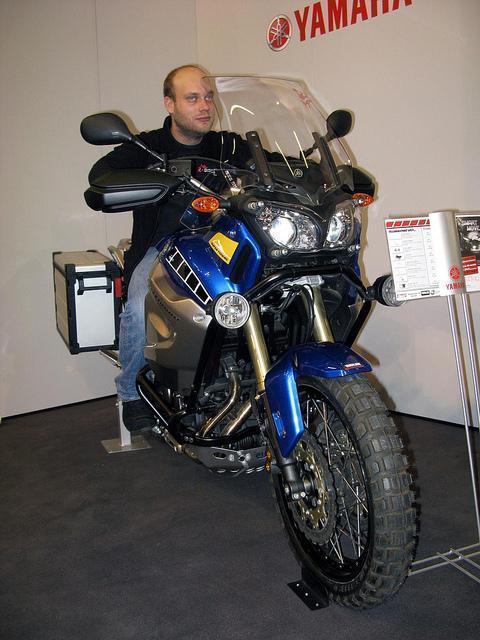What brand is the motorcycle?
Pick the correct solution from the four options below to address the question.
Options: Yamaha, harley, honda, suzuki. Yamaha. 